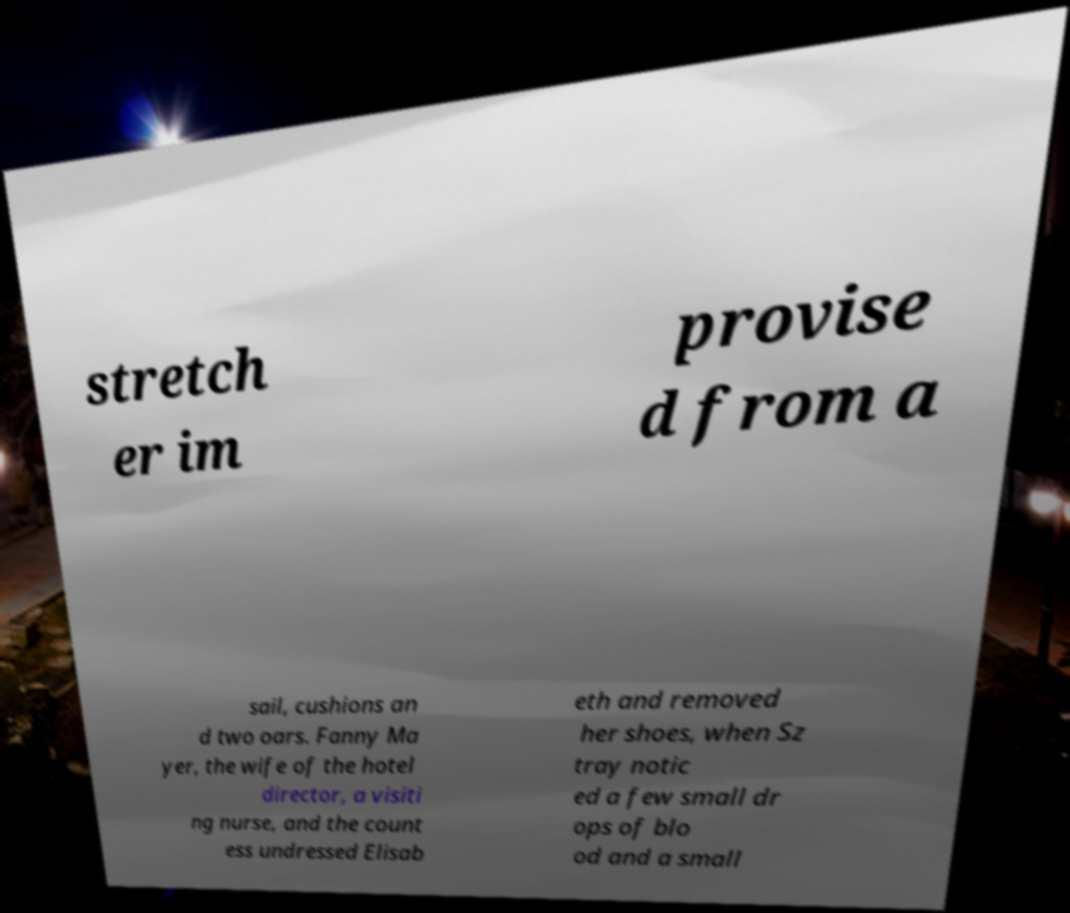There's text embedded in this image that I need extracted. Can you transcribe it verbatim? stretch er im provise d from a sail, cushions an d two oars. Fanny Ma yer, the wife of the hotel director, a visiti ng nurse, and the count ess undressed Elisab eth and removed her shoes, when Sz tray notic ed a few small dr ops of blo od and a small 